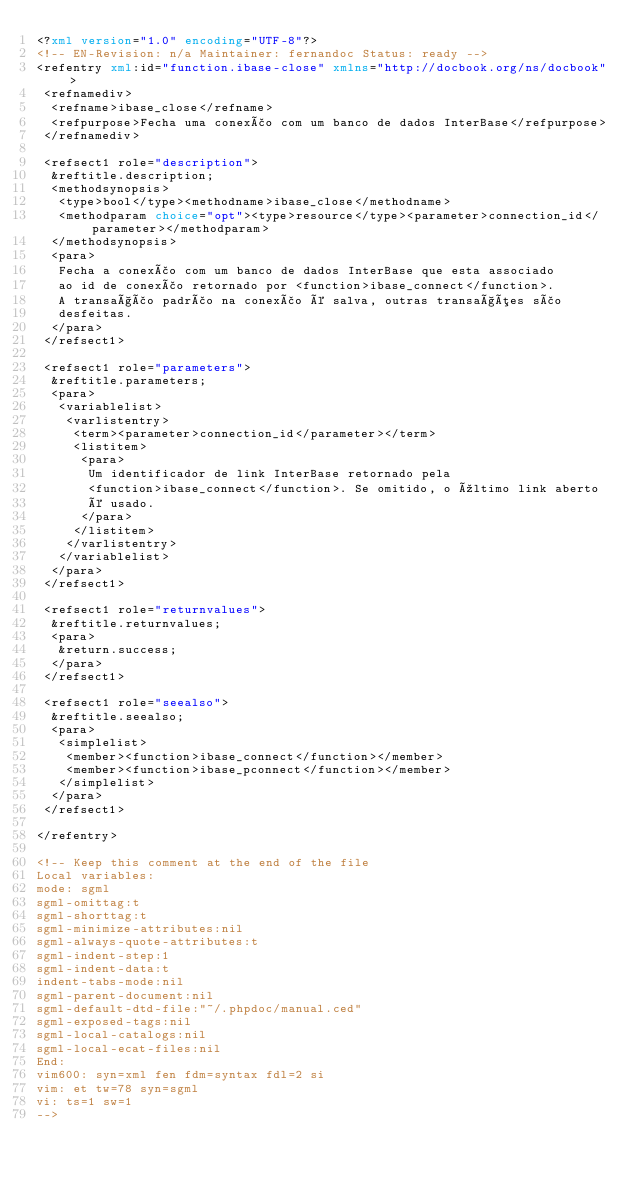<code> <loc_0><loc_0><loc_500><loc_500><_XML_><?xml version="1.0" encoding="UTF-8"?>
<!-- EN-Revision: n/a Maintainer: fernandoc Status: ready -->
<refentry xml:id="function.ibase-close" xmlns="http://docbook.org/ns/docbook">
 <refnamediv>
  <refname>ibase_close</refname>
  <refpurpose>Fecha uma conexão com um banco de dados InterBase</refpurpose>
 </refnamediv>
 
 <refsect1 role="description">
  &reftitle.description;
  <methodsynopsis>
   <type>bool</type><methodname>ibase_close</methodname>
   <methodparam choice="opt"><type>resource</type><parameter>connection_id</parameter></methodparam>
  </methodsynopsis>
  <para>
   Fecha a conexão com um banco de dados InterBase que esta associado
   ao id de conexão retornado por <function>ibase_connect</function>.
   A transação padrão na conexão é salva, outras transações são
   desfeitas.
  </para>
 </refsect1>

 <refsect1 role="parameters">
  &reftitle.parameters;
  <para>
   <variablelist>
    <varlistentry>
     <term><parameter>connection_id</parameter></term>
     <listitem>
      <para>
       Um identificador de link InterBase retornado pela
       <function>ibase_connect</function>. Se omitido, o último link aberto
       é usado.
      </para>
     </listitem>
    </varlistentry>
   </variablelist>
  </para>
 </refsect1>

 <refsect1 role="returnvalues">
  &reftitle.returnvalues;
  <para>
   &return.success;
  </para>
 </refsect1>

 <refsect1 role="seealso">
  &reftitle.seealso;
  <para>
   <simplelist>
    <member><function>ibase_connect</function></member>
    <member><function>ibase_pconnect</function></member>
   </simplelist>
  </para>
 </refsect1>
 
</refentry>

<!-- Keep this comment at the end of the file
Local variables:
mode: sgml
sgml-omittag:t
sgml-shorttag:t
sgml-minimize-attributes:nil
sgml-always-quote-attributes:t
sgml-indent-step:1
sgml-indent-data:t
indent-tabs-mode:nil
sgml-parent-document:nil
sgml-default-dtd-file:"~/.phpdoc/manual.ced"
sgml-exposed-tags:nil
sgml-local-catalogs:nil
sgml-local-ecat-files:nil
End:
vim600: syn=xml fen fdm=syntax fdl=2 si
vim: et tw=78 syn=sgml
vi: ts=1 sw=1
-->
</code> 